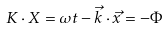Convert formula to latex. <formula><loc_0><loc_0><loc_500><loc_500>K \cdot X = \omega t - { \vec { k } } \cdot { \vec { x } } = - \Phi</formula> 